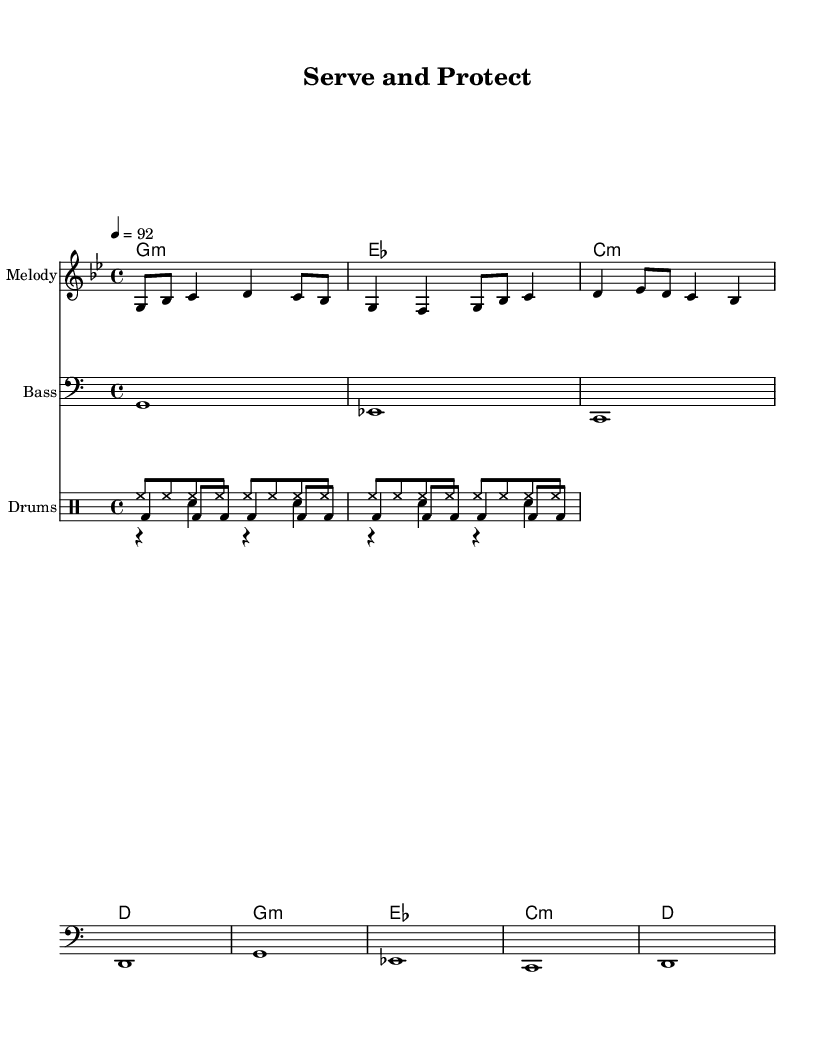What is the key signature of this music? The key signature is G minor, which has two flats (B♭ and E♭). This can be determined by looking for the key signature notation at the beginning of the staff, indicating the tonal center.
Answer: G minor What is the time signature of this piece? The time signature is 4/4, meaning there are four beats in each measure, and the quarter note gets one beat. This is evident from the notation displayed at the start of the score.
Answer: 4/4 What is the tempo marking indicated in the music? The tempo marking indicates a speed of 92 beats per minute. This is stated in the tempo line where "4 = 92" appears, showing the tempo context for performance.
Answer: 92 How many measures are in the melody section? The melody section comprises four measures, which can be counted by looking at the bar lines that separate each measure in the staff.
Answer: 4 What style of music is this piece classified as? This piece is classified as Rap, suggested by the lyrical content and rhythmic structure, which aligns with motivational themes typically found in rap anthems.
Answer: Rap How many instruments are included in this score? There are four instruments included: Melody, Bass, and three types of drums (Hi-Hat, Snare, and Bass Drum), as indicated by the score layout showing multiple staves.
Answer: 4 